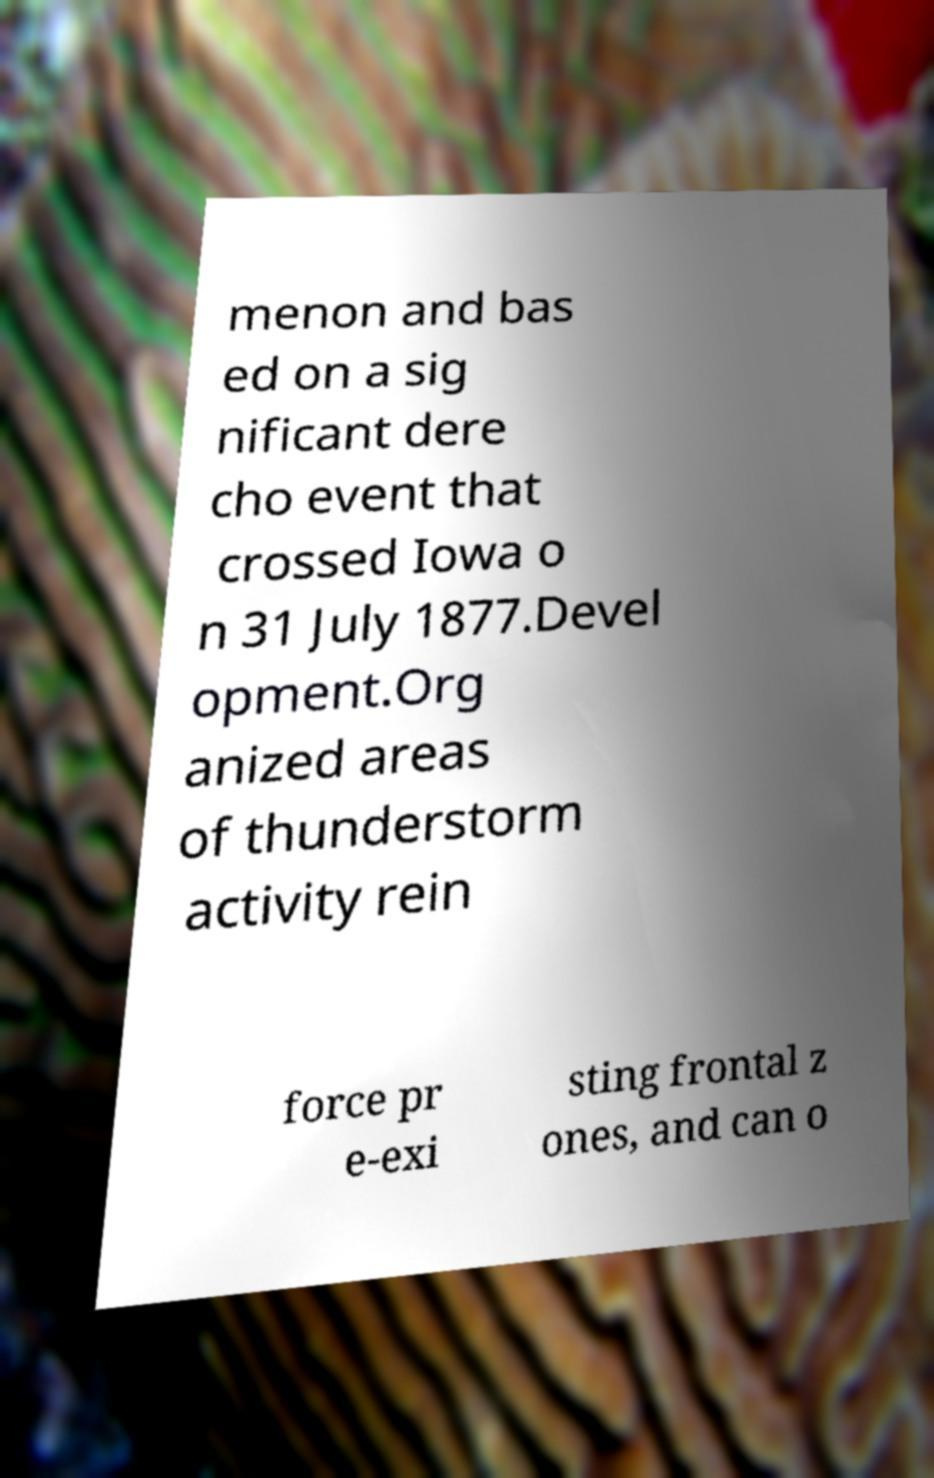For documentation purposes, I need the text within this image transcribed. Could you provide that? menon and bas ed on a sig nificant dere cho event that crossed Iowa o n 31 July 1877.Devel opment.Org anized areas of thunderstorm activity rein force pr e-exi sting frontal z ones, and can o 